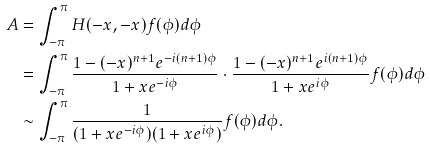<formula> <loc_0><loc_0><loc_500><loc_500>A & = \int _ { - \pi } ^ { \pi } H ( - x , - x ) f ( \phi ) d \phi \\ & = \int _ { - \pi } ^ { \pi } \frac { 1 - ( - x ) ^ { n + 1 } e ^ { - i ( n + 1 ) \phi } } { 1 + x e ^ { - i \phi } } \cdot \frac { 1 - ( - x ) ^ { n + 1 } e ^ { i ( n + 1 ) \phi } } { 1 + x e ^ { i \phi } } f ( \phi ) d \phi \\ & \sim \int _ { - \pi } ^ { \pi } \frac { 1 } { ( 1 + x e ^ { - i \phi } ) ( 1 + x e ^ { i \phi } ) } f ( \phi ) d \phi . \\</formula> 